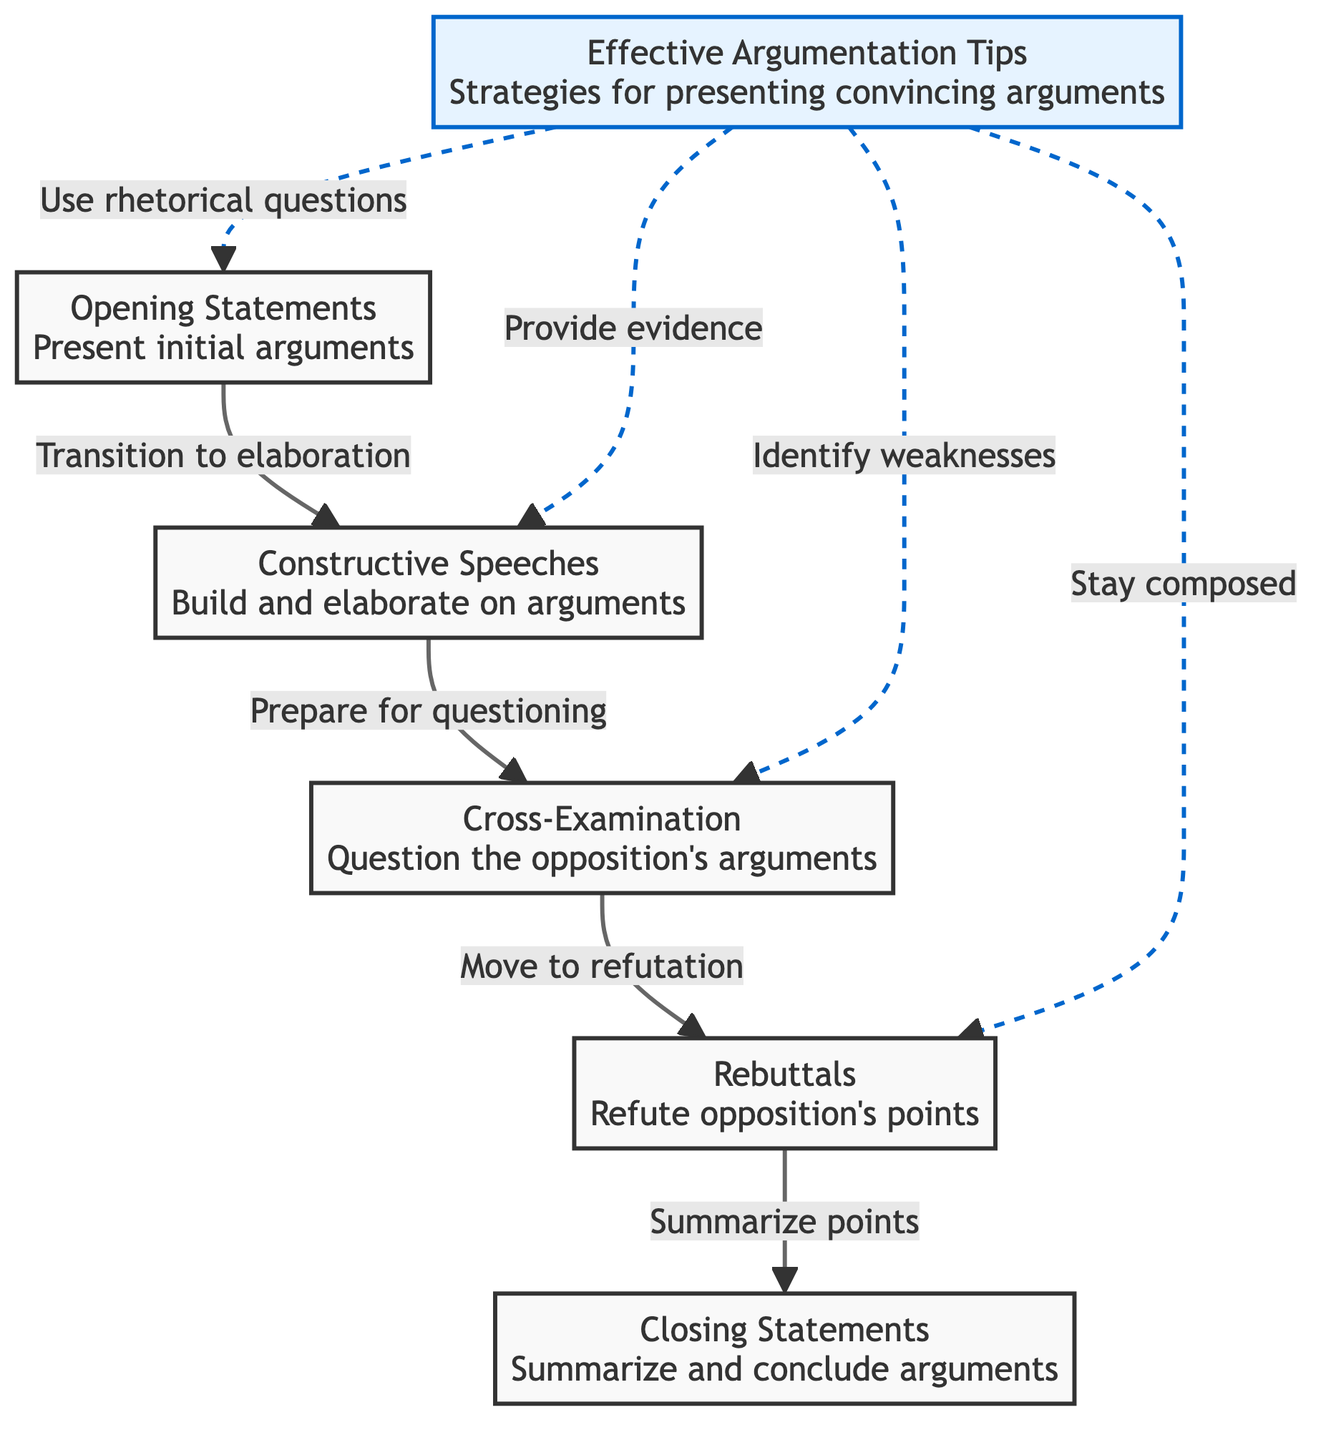What are the components of a classic debate? The diagram lists five main components: Opening Statements, Constructive Speeches, Cross-Examination, Rebuttals, and Closing Statements. Each of these represents a crucial part of the debate structure.
Answer: Opening Statements, Constructive Speeches, Cross-Examination, Rebuttals, Closing Statements What does the node labeled '6' represent? Node '6' is labeled 'Effective Argumentation Tips' and provides strategies for presenting convincing arguments in a debate. It is distinct from the other components as it focuses on techniques rather than structural elements.
Answer: Effective Argumentation Tips How many components are directly involved in the flow of a debate? The diagram shows a direct flow connecting five main components from Opening Statements to Closing Statements, accounting for each essential stage in the debate process.
Answer: Five What is the transition from Constructive Speeches to the next component? The arrow in the diagram indicates that the transition from Constructive Speeches leads to Cross-Examination, which involves questioning the opposition’s arguments.
Answer: Move to refutation Which node connects to the Rebuttals component? The diagram shows that Cross-Examination connects directly to the Rebuttals component, indicating that it is the next step following the questioning phase.
Answer: Cross-Examination What strategies are suggested for the opening statements? The diagram points to 'Use rhetorical questions' as a strategy for effective argumentation during Opening Statements, suggesting a technique to engage the audience.
Answer: Use rhetorical questions How is the Closing Statements connected to the previous components? The Closing Statements come after Rebuttals, as shown in the flow of the diagram, indicating that they summarize and conclude the arguments made throughout the debate process.
Answer: Summarize points What is the significance of the dashed lines in the diagram? The dashed lines signal tips or strategies that link to the various components, indicating that these strategies can enhance effectiveness at each stage rather than being essential steps in the progression of the debate.
Answer: Enhancement strategies Which component follows the Cross-Examination? The diagram outlines that the next component after Cross-Examination is Rebuttals, indicating this is where arguments are refuted.
Answer: Rebuttals 